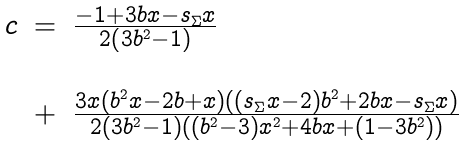<formula> <loc_0><loc_0><loc_500><loc_500>\begin{array} { c c l } c & = & \frac { - 1 + 3 b x - s _ { \Sigma } x } { 2 \left ( 3 b ^ { 2 } - 1 \right ) } \\ \\ & + & \frac { 3 x \left ( b ^ { 2 } x - 2 b + x \right ) \left ( ( s _ { \Sigma } x - 2 ) b ^ { 2 } + 2 b x - s _ { \Sigma } x \right ) } { 2 ( 3 b ^ { 2 } - 1 ) ( ( b ^ { 2 } - 3 ) x ^ { 2 } + 4 b x + ( 1 - 3 b ^ { 2 } ) ) } \end{array}</formula> 